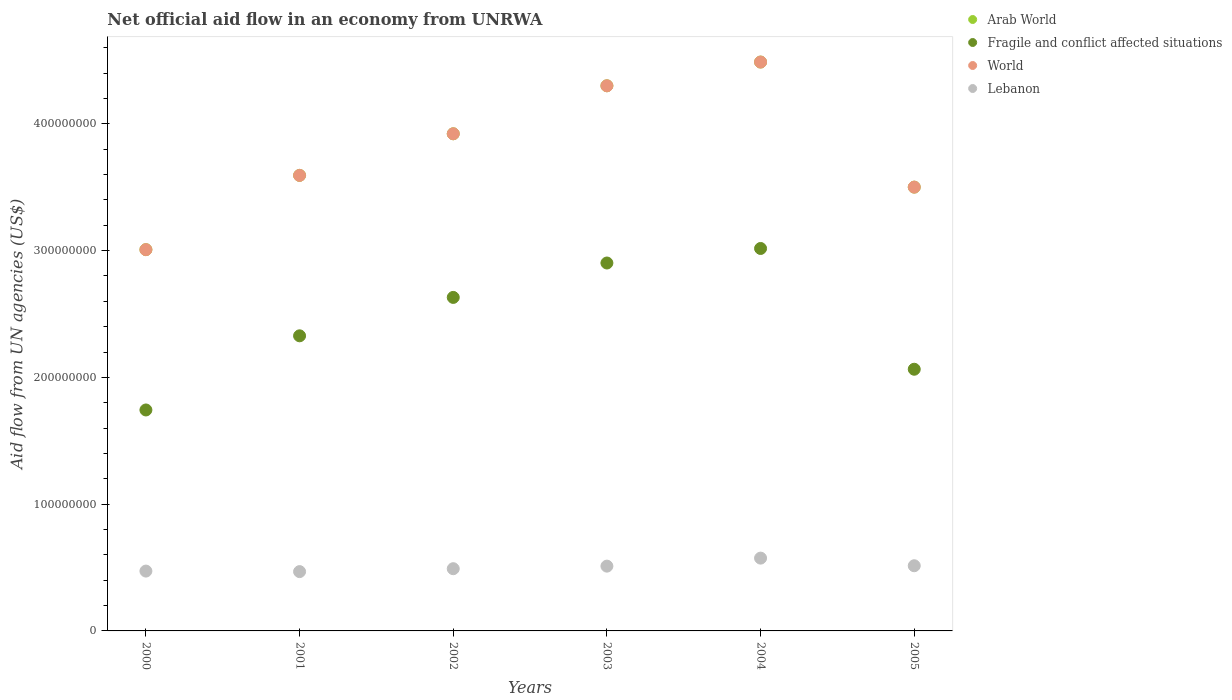How many different coloured dotlines are there?
Your answer should be very brief. 4. What is the net official aid flow in Lebanon in 2002?
Offer a terse response. 4.91e+07. Across all years, what is the maximum net official aid flow in Lebanon?
Offer a terse response. 5.74e+07. Across all years, what is the minimum net official aid flow in Fragile and conflict affected situations?
Make the answer very short. 1.74e+08. In which year was the net official aid flow in Lebanon maximum?
Your response must be concise. 2004. In which year was the net official aid flow in World minimum?
Provide a succinct answer. 2000. What is the total net official aid flow in Lebanon in the graph?
Provide a short and direct response. 3.03e+08. What is the difference between the net official aid flow in Arab World in 2001 and that in 2002?
Give a very brief answer. -3.28e+07. What is the difference between the net official aid flow in Fragile and conflict affected situations in 2004 and the net official aid flow in Lebanon in 2005?
Your response must be concise. 2.50e+08. What is the average net official aid flow in Lebanon per year?
Your answer should be very brief. 5.05e+07. In the year 2000, what is the difference between the net official aid flow in Fragile and conflict affected situations and net official aid flow in Arab World?
Your answer should be very brief. -1.26e+08. What is the ratio of the net official aid flow in World in 2002 to that in 2005?
Keep it short and to the point. 1.12. Is the net official aid flow in World in 2002 less than that in 2004?
Offer a terse response. Yes. Is the difference between the net official aid flow in Fragile and conflict affected situations in 2002 and 2005 greater than the difference between the net official aid flow in Arab World in 2002 and 2005?
Keep it short and to the point. Yes. What is the difference between the highest and the second highest net official aid flow in Arab World?
Keep it short and to the point. 1.87e+07. What is the difference between the highest and the lowest net official aid flow in Lebanon?
Your answer should be compact. 1.06e+07. In how many years, is the net official aid flow in World greater than the average net official aid flow in World taken over all years?
Offer a terse response. 3. Is it the case that in every year, the sum of the net official aid flow in Arab World and net official aid flow in World  is greater than the sum of net official aid flow in Lebanon and net official aid flow in Fragile and conflict affected situations?
Your answer should be very brief. No. Does the net official aid flow in Arab World monotonically increase over the years?
Give a very brief answer. No. How many dotlines are there?
Offer a very short reply. 4. How many years are there in the graph?
Give a very brief answer. 6. What is the difference between two consecutive major ticks on the Y-axis?
Offer a terse response. 1.00e+08. Are the values on the major ticks of Y-axis written in scientific E-notation?
Offer a terse response. No. Does the graph contain grids?
Your answer should be compact. No. Where does the legend appear in the graph?
Keep it short and to the point. Top right. How many legend labels are there?
Keep it short and to the point. 4. How are the legend labels stacked?
Your response must be concise. Vertical. What is the title of the graph?
Your response must be concise. Net official aid flow in an economy from UNRWA. What is the label or title of the Y-axis?
Provide a succinct answer. Aid flow from UN agencies (US$). What is the Aid flow from UN agencies (US$) of Arab World in 2000?
Give a very brief answer. 3.01e+08. What is the Aid flow from UN agencies (US$) in Fragile and conflict affected situations in 2000?
Your answer should be compact. 1.74e+08. What is the Aid flow from UN agencies (US$) of World in 2000?
Provide a succinct answer. 3.01e+08. What is the Aid flow from UN agencies (US$) of Lebanon in 2000?
Keep it short and to the point. 4.72e+07. What is the Aid flow from UN agencies (US$) of Arab World in 2001?
Ensure brevity in your answer.  3.59e+08. What is the Aid flow from UN agencies (US$) in Fragile and conflict affected situations in 2001?
Make the answer very short. 2.33e+08. What is the Aid flow from UN agencies (US$) in World in 2001?
Keep it short and to the point. 3.59e+08. What is the Aid flow from UN agencies (US$) in Lebanon in 2001?
Your answer should be compact. 4.68e+07. What is the Aid flow from UN agencies (US$) of Arab World in 2002?
Your response must be concise. 3.92e+08. What is the Aid flow from UN agencies (US$) in Fragile and conflict affected situations in 2002?
Keep it short and to the point. 2.63e+08. What is the Aid flow from UN agencies (US$) of World in 2002?
Your response must be concise. 3.92e+08. What is the Aid flow from UN agencies (US$) of Lebanon in 2002?
Your answer should be very brief. 4.91e+07. What is the Aid flow from UN agencies (US$) in Arab World in 2003?
Offer a terse response. 4.30e+08. What is the Aid flow from UN agencies (US$) in Fragile and conflict affected situations in 2003?
Your answer should be compact. 2.90e+08. What is the Aid flow from UN agencies (US$) of World in 2003?
Your answer should be compact. 4.30e+08. What is the Aid flow from UN agencies (US$) in Lebanon in 2003?
Give a very brief answer. 5.11e+07. What is the Aid flow from UN agencies (US$) of Arab World in 2004?
Ensure brevity in your answer.  4.49e+08. What is the Aid flow from UN agencies (US$) of Fragile and conflict affected situations in 2004?
Provide a succinct answer. 3.02e+08. What is the Aid flow from UN agencies (US$) in World in 2004?
Ensure brevity in your answer.  4.49e+08. What is the Aid flow from UN agencies (US$) in Lebanon in 2004?
Make the answer very short. 5.74e+07. What is the Aid flow from UN agencies (US$) of Arab World in 2005?
Make the answer very short. 3.50e+08. What is the Aid flow from UN agencies (US$) of Fragile and conflict affected situations in 2005?
Give a very brief answer. 2.06e+08. What is the Aid flow from UN agencies (US$) in World in 2005?
Your answer should be very brief. 3.50e+08. What is the Aid flow from UN agencies (US$) in Lebanon in 2005?
Provide a short and direct response. 5.14e+07. Across all years, what is the maximum Aid flow from UN agencies (US$) in Arab World?
Ensure brevity in your answer.  4.49e+08. Across all years, what is the maximum Aid flow from UN agencies (US$) in Fragile and conflict affected situations?
Make the answer very short. 3.02e+08. Across all years, what is the maximum Aid flow from UN agencies (US$) of World?
Provide a succinct answer. 4.49e+08. Across all years, what is the maximum Aid flow from UN agencies (US$) of Lebanon?
Your answer should be very brief. 5.74e+07. Across all years, what is the minimum Aid flow from UN agencies (US$) in Arab World?
Ensure brevity in your answer.  3.01e+08. Across all years, what is the minimum Aid flow from UN agencies (US$) in Fragile and conflict affected situations?
Ensure brevity in your answer.  1.74e+08. Across all years, what is the minimum Aid flow from UN agencies (US$) in World?
Keep it short and to the point. 3.01e+08. Across all years, what is the minimum Aid flow from UN agencies (US$) of Lebanon?
Provide a short and direct response. 4.68e+07. What is the total Aid flow from UN agencies (US$) of Arab World in the graph?
Keep it short and to the point. 2.28e+09. What is the total Aid flow from UN agencies (US$) in Fragile and conflict affected situations in the graph?
Your answer should be compact. 1.47e+09. What is the total Aid flow from UN agencies (US$) in World in the graph?
Your answer should be very brief. 2.28e+09. What is the total Aid flow from UN agencies (US$) in Lebanon in the graph?
Provide a succinct answer. 3.03e+08. What is the difference between the Aid flow from UN agencies (US$) of Arab World in 2000 and that in 2001?
Provide a succinct answer. -5.86e+07. What is the difference between the Aid flow from UN agencies (US$) of Fragile and conflict affected situations in 2000 and that in 2001?
Your answer should be very brief. -5.85e+07. What is the difference between the Aid flow from UN agencies (US$) in World in 2000 and that in 2001?
Keep it short and to the point. -5.86e+07. What is the difference between the Aid flow from UN agencies (US$) of Lebanon in 2000 and that in 2001?
Provide a short and direct response. 4.20e+05. What is the difference between the Aid flow from UN agencies (US$) in Arab World in 2000 and that in 2002?
Provide a short and direct response. -9.14e+07. What is the difference between the Aid flow from UN agencies (US$) of Fragile and conflict affected situations in 2000 and that in 2002?
Make the answer very short. -8.88e+07. What is the difference between the Aid flow from UN agencies (US$) in World in 2000 and that in 2002?
Your response must be concise. -9.14e+07. What is the difference between the Aid flow from UN agencies (US$) in Lebanon in 2000 and that in 2002?
Provide a succinct answer. -1.88e+06. What is the difference between the Aid flow from UN agencies (US$) of Arab World in 2000 and that in 2003?
Your response must be concise. -1.29e+08. What is the difference between the Aid flow from UN agencies (US$) of Fragile and conflict affected situations in 2000 and that in 2003?
Make the answer very short. -1.16e+08. What is the difference between the Aid flow from UN agencies (US$) in World in 2000 and that in 2003?
Your answer should be compact. -1.29e+08. What is the difference between the Aid flow from UN agencies (US$) of Lebanon in 2000 and that in 2003?
Provide a short and direct response. -3.90e+06. What is the difference between the Aid flow from UN agencies (US$) in Arab World in 2000 and that in 2004?
Your response must be concise. -1.48e+08. What is the difference between the Aid flow from UN agencies (US$) of Fragile and conflict affected situations in 2000 and that in 2004?
Ensure brevity in your answer.  -1.27e+08. What is the difference between the Aid flow from UN agencies (US$) of World in 2000 and that in 2004?
Your answer should be very brief. -1.48e+08. What is the difference between the Aid flow from UN agencies (US$) in Lebanon in 2000 and that in 2004?
Provide a succinct answer. -1.02e+07. What is the difference between the Aid flow from UN agencies (US$) in Arab World in 2000 and that in 2005?
Provide a succinct answer. -4.93e+07. What is the difference between the Aid flow from UN agencies (US$) of Fragile and conflict affected situations in 2000 and that in 2005?
Offer a terse response. -3.21e+07. What is the difference between the Aid flow from UN agencies (US$) of World in 2000 and that in 2005?
Offer a very short reply. -4.93e+07. What is the difference between the Aid flow from UN agencies (US$) in Lebanon in 2000 and that in 2005?
Make the answer very short. -4.21e+06. What is the difference between the Aid flow from UN agencies (US$) in Arab World in 2001 and that in 2002?
Make the answer very short. -3.28e+07. What is the difference between the Aid flow from UN agencies (US$) of Fragile and conflict affected situations in 2001 and that in 2002?
Your answer should be very brief. -3.03e+07. What is the difference between the Aid flow from UN agencies (US$) in World in 2001 and that in 2002?
Ensure brevity in your answer.  -3.28e+07. What is the difference between the Aid flow from UN agencies (US$) in Lebanon in 2001 and that in 2002?
Provide a short and direct response. -2.30e+06. What is the difference between the Aid flow from UN agencies (US$) of Arab World in 2001 and that in 2003?
Offer a terse response. -7.07e+07. What is the difference between the Aid flow from UN agencies (US$) of Fragile and conflict affected situations in 2001 and that in 2003?
Your answer should be compact. -5.74e+07. What is the difference between the Aid flow from UN agencies (US$) of World in 2001 and that in 2003?
Provide a succinct answer. -7.07e+07. What is the difference between the Aid flow from UN agencies (US$) in Lebanon in 2001 and that in 2003?
Give a very brief answer. -4.32e+06. What is the difference between the Aid flow from UN agencies (US$) in Arab World in 2001 and that in 2004?
Make the answer very short. -8.94e+07. What is the difference between the Aid flow from UN agencies (US$) in Fragile and conflict affected situations in 2001 and that in 2004?
Make the answer very short. -6.89e+07. What is the difference between the Aid flow from UN agencies (US$) of World in 2001 and that in 2004?
Your response must be concise. -8.94e+07. What is the difference between the Aid flow from UN agencies (US$) of Lebanon in 2001 and that in 2004?
Provide a succinct answer. -1.06e+07. What is the difference between the Aid flow from UN agencies (US$) of Arab World in 2001 and that in 2005?
Provide a succinct answer. 9.26e+06. What is the difference between the Aid flow from UN agencies (US$) in Fragile and conflict affected situations in 2001 and that in 2005?
Provide a succinct answer. 2.64e+07. What is the difference between the Aid flow from UN agencies (US$) of World in 2001 and that in 2005?
Keep it short and to the point. 9.26e+06. What is the difference between the Aid flow from UN agencies (US$) in Lebanon in 2001 and that in 2005?
Your answer should be very brief. -4.63e+06. What is the difference between the Aid flow from UN agencies (US$) of Arab World in 2002 and that in 2003?
Provide a succinct answer. -3.79e+07. What is the difference between the Aid flow from UN agencies (US$) in Fragile and conflict affected situations in 2002 and that in 2003?
Your answer should be compact. -2.72e+07. What is the difference between the Aid flow from UN agencies (US$) in World in 2002 and that in 2003?
Your response must be concise. -3.79e+07. What is the difference between the Aid flow from UN agencies (US$) in Lebanon in 2002 and that in 2003?
Give a very brief answer. -2.02e+06. What is the difference between the Aid flow from UN agencies (US$) in Arab World in 2002 and that in 2004?
Your answer should be very brief. -5.66e+07. What is the difference between the Aid flow from UN agencies (US$) of Fragile and conflict affected situations in 2002 and that in 2004?
Provide a short and direct response. -3.86e+07. What is the difference between the Aid flow from UN agencies (US$) of World in 2002 and that in 2004?
Your response must be concise. -5.66e+07. What is the difference between the Aid flow from UN agencies (US$) of Lebanon in 2002 and that in 2004?
Provide a short and direct response. -8.34e+06. What is the difference between the Aid flow from UN agencies (US$) of Arab World in 2002 and that in 2005?
Provide a succinct answer. 4.21e+07. What is the difference between the Aid flow from UN agencies (US$) of Fragile and conflict affected situations in 2002 and that in 2005?
Your response must be concise. 5.67e+07. What is the difference between the Aid flow from UN agencies (US$) in World in 2002 and that in 2005?
Offer a terse response. 4.21e+07. What is the difference between the Aid flow from UN agencies (US$) in Lebanon in 2002 and that in 2005?
Your response must be concise. -2.33e+06. What is the difference between the Aid flow from UN agencies (US$) of Arab World in 2003 and that in 2004?
Offer a very short reply. -1.87e+07. What is the difference between the Aid flow from UN agencies (US$) of Fragile and conflict affected situations in 2003 and that in 2004?
Offer a terse response. -1.15e+07. What is the difference between the Aid flow from UN agencies (US$) in World in 2003 and that in 2004?
Offer a terse response. -1.87e+07. What is the difference between the Aid flow from UN agencies (US$) of Lebanon in 2003 and that in 2004?
Make the answer very short. -6.32e+06. What is the difference between the Aid flow from UN agencies (US$) in Arab World in 2003 and that in 2005?
Offer a very short reply. 8.00e+07. What is the difference between the Aid flow from UN agencies (US$) in Fragile and conflict affected situations in 2003 and that in 2005?
Ensure brevity in your answer.  8.38e+07. What is the difference between the Aid flow from UN agencies (US$) in World in 2003 and that in 2005?
Offer a terse response. 8.00e+07. What is the difference between the Aid flow from UN agencies (US$) of Lebanon in 2003 and that in 2005?
Provide a succinct answer. -3.10e+05. What is the difference between the Aid flow from UN agencies (US$) in Arab World in 2004 and that in 2005?
Provide a succinct answer. 9.87e+07. What is the difference between the Aid flow from UN agencies (US$) of Fragile and conflict affected situations in 2004 and that in 2005?
Provide a succinct answer. 9.53e+07. What is the difference between the Aid flow from UN agencies (US$) of World in 2004 and that in 2005?
Keep it short and to the point. 9.87e+07. What is the difference between the Aid flow from UN agencies (US$) in Lebanon in 2004 and that in 2005?
Provide a succinct answer. 6.01e+06. What is the difference between the Aid flow from UN agencies (US$) of Arab World in 2000 and the Aid flow from UN agencies (US$) of Fragile and conflict affected situations in 2001?
Keep it short and to the point. 6.80e+07. What is the difference between the Aid flow from UN agencies (US$) in Arab World in 2000 and the Aid flow from UN agencies (US$) in World in 2001?
Offer a very short reply. -5.86e+07. What is the difference between the Aid flow from UN agencies (US$) of Arab World in 2000 and the Aid flow from UN agencies (US$) of Lebanon in 2001?
Give a very brief answer. 2.54e+08. What is the difference between the Aid flow from UN agencies (US$) in Fragile and conflict affected situations in 2000 and the Aid flow from UN agencies (US$) in World in 2001?
Offer a very short reply. -1.85e+08. What is the difference between the Aid flow from UN agencies (US$) of Fragile and conflict affected situations in 2000 and the Aid flow from UN agencies (US$) of Lebanon in 2001?
Ensure brevity in your answer.  1.28e+08. What is the difference between the Aid flow from UN agencies (US$) in World in 2000 and the Aid flow from UN agencies (US$) in Lebanon in 2001?
Give a very brief answer. 2.54e+08. What is the difference between the Aid flow from UN agencies (US$) of Arab World in 2000 and the Aid flow from UN agencies (US$) of Fragile and conflict affected situations in 2002?
Keep it short and to the point. 3.77e+07. What is the difference between the Aid flow from UN agencies (US$) of Arab World in 2000 and the Aid flow from UN agencies (US$) of World in 2002?
Your answer should be very brief. -9.14e+07. What is the difference between the Aid flow from UN agencies (US$) in Arab World in 2000 and the Aid flow from UN agencies (US$) in Lebanon in 2002?
Offer a terse response. 2.52e+08. What is the difference between the Aid flow from UN agencies (US$) of Fragile and conflict affected situations in 2000 and the Aid flow from UN agencies (US$) of World in 2002?
Offer a very short reply. -2.18e+08. What is the difference between the Aid flow from UN agencies (US$) in Fragile and conflict affected situations in 2000 and the Aid flow from UN agencies (US$) in Lebanon in 2002?
Your response must be concise. 1.25e+08. What is the difference between the Aid flow from UN agencies (US$) of World in 2000 and the Aid flow from UN agencies (US$) of Lebanon in 2002?
Your answer should be compact. 2.52e+08. What is the difference between the Aid flow from UN agencies (US$) of Arab World in 2000 and the Aid flow from UN agencies (US$) of Fragile and conflict affected situations in 2003?
Make the answer very short. 1.05e+07. What is the difference between the Aid flow from UN agencies (US$) of Arab World in 2000 and the Aid flow from UN agencies (US$) of World in 2003?
Your answer should be very brief. -1.29e+08. What is the difference between the Aid flow from UN agencies (US$) in Arab World in 2000 and the Aid flow from UN agencies (US$) in Lebanon in 2003?
Provide a succinct answer. 2.50e+08. What is the difference between the Aid flow from UN agencies (US$) in Fragile and conflict affected situations in 2000 and the Aid flow from UN agencies (US$) in World in 2003?
Make the answer very short. -2.56e+08. What is the difference between the Aid flow from UN agencies (US$) of Fragile and conflict affected situations in 2000 and the Aid flow from UN agencies (US$) of Lebanon in 2003?
Ensure brevity in your answer.  1.23e+08. What is the difference between the Aid flow from UN agencies (US$) of World in 2000 and the Aid flow from UN agencies (US$) of Lebanon in 2003?
Give a very brief answer. 2.50e+08. What is the difference between the Aid flow from UN agencies (US$) in Arab World in 2000 and the Aid flow from UN agencies (US$) in Fragile and conflict affected situations in 2004?
Provide a succinct answer. -9.30e+05. What is the difference between the Aid flow from UN agencies (US$) of Arab World in 2000 and the Aid flow from UN agencies (US$) of World in 2004?
Offer a terse response. -1.48e+08. What is the difference between the Aid flow from UN agencies (US$) of Arab World in 2000 and the Aid flow from UN agencies (US$) of Lebanon in 2004?
Ensure brevity in your answer.  2.43e+08. What is the difference between the Aid flow from UN agencies (US$) in Fragile and conflict affected situations in 2000 and the Aid flow from UN agencies (US$) in World in 2004?
Make the answer very short. -2.74e+08. What is the difference between the Aid flow from UN agencies (US$) in Fragile and conflict affected situations in 2000 and the Aid flow from UN agencies (US$) in Lebanon in 2004?
Keep it short and to the point. 1.17e+08. What is the difference between the Aid flow from UN agencies (US$) of World in 2000 and the Aid flow from UN agencies (US$) of Lebanon in 2004?
Your answer should be very brief. 2.43e+08. What is the difference between the Aid flow from UN agencies (US$) of Arab World in 2000 and the Aid flow from UN agencies (US$) of Fragile and conflict affected situations in 2005?
Provide a succinct answer. 9.43e+07. What is the difference between the Aid flow from UN agencies (US$) in Arab World in 2000 and the Aid flow from UN agencies (US$) in World in 2005?
Offer a very short reply. -4.93e+07. What is the difference between the Aid flow from UN agencies (US$) of Arab World in 2000 and the Aid flow from UN agencies (US$) of Lebanon in 2005?
Your response must be concise. 2.49e+08. What is the difference between the Aid flow from UN agencies (US$) of Fragile and conflict affected situations in 2000 and the Aid flow from UN agencies (US$) of World in 2005?
Provide a short and direct response. -1.76e+08. What is the difference between the Aid flow from UN agencies (US$) of Fragile and conflict affected situations in 2000 and the Aid flow from UN agencies (US$) of Lebanon in 2005?
Make the answer very short. 1.23e+08. What is the difference between the Aid flow from UN agencies (US$) in World in 2000 and the Aid flow from UN agencies (US$) in Lebanon in 2005?
Offer a very short reply. 2.49e+08. What is the difference between the Aid flow from UN agencies (US$) of Arab World in 2001 and the Aid flow from UN agencies (US$) of Fragile and conflict affected situations in 2002?
Keep it short and to the point. 9.63e+07. What is the difference between the Aid flow from UN agencies (US$) of Arab World in 2001 and the Aid flow from UN agencies (US$) of World in 2002?
Your answer should be compact. -3.28e+07. What is the difference between the Aid flow from UN agencies (US$) in Arab World in 2001 and the Aid flow from UN agencies (US$) in Lebanon in 2002?
Make the answer very short. 3.10e+08. What is the difference between the Aid flow from UN agencies (US$) in Fragile and conflict affected situations in 2001 and the Aid flow from UN agencies (US$) in World in 2002?
Provide a succinct answer. -1.59e+08. What is the difference between the Aid flow from UN agencies (US$) of Fragile and conflict affected situations in 2001 and the Aid flow from UN agencies (US$) of Lebanon in 2002?
Your response must be concise. 1.84e+08. What is the difference between the Aid flow from UN agencies (US$) in World in 2001 and the Aid flow from UN agencies (US$) in Lebanon in 2002?
Your answer should be very brief. 3.10e+08. What is the difference between the Aid flow from UN agencies (US$) of Arab World in 2001 and the Aid flow from UN agencies (US$) of Fragile and conflict affected situations in 2003?
Offer a very short reply. 6.91e+07. What is the difference between the Aid flow from UN agencies (US$) of Arab World in 2001 and the Aid flow from UN agencies (US$) of World in 2003?
Your answer should be very brief. -7.07e+07. What is the difference between the Aid flow from UN agencies (US$) in Arab World in 2001 and the Aid flow from UN agencies (US$) in Lebanon in 2003?
Provide a succinct answer. 3.08e+08. What is the difference between the Aid flow from UN agencies (US$) in Fragile and conflict affected situations in 2001 and the Aid flow from UN agencies (US$) in World in 2003?
Offer a very short reply. -1.97e+08. What is the difference between the Aid flow from UN agencies (US$) in Fragile and conflict affected situations in 2001 and the Aid flow from UN agencies (US$) in Lebanon in 2003?
Give a very brief answer. 1.82e+08. What is the difference between the Aid flow from UN agencies (US$) of World in 2001 and the Aid flow from UN agencies (US$) of Lebanon in 2003?
Your answer should be very brief. 3.08e+08. What is the difference between the Aid flow from UN agencies (US$) of Arab World in 2001 and the Aid flow from UN agencies (US$) of Fragile and conflict affected situations in 2004?
Offer a very short reply. 5.77e+07. What is the difference between the Aid flow from UN agencies (US$) of Arab World in 2001 and the Aid flow from UN agencies (US$) of World in 2004?
Your answer should be compact. -8.94e+07. What is the difference between the Aid flow from UN agencies (US$) of Arab World in 2001 and the Aid flow from UN agencies (US$) of Lebanon in 2004?
Provide a succinct answer. 3.02e+08. What is the difference between the Aid flow from UN agencies (US$) of Fragile and conflict affected situations in 2001 and the Aid flow from UN agencies (US$) of World in 2004?
Provide a succinct answer. -2.16e+08. What is the difference between the Aid flow from UN agencies (US$) in Fragile and conflict affected situations in 2001 and the Aid flow from UN agencies (US$) in Lebanon in 2004?
Provide a succinct answer. 1.75e+08. What is the difference between the Aid flow from UN agencies (US$) in World in 2001 and the Aid flow from UN agencies (US$) in Lebanon in 2004?
Keep it short and to the point. 3.02e+08. What is the difference between the Aid flow from UN agencies (US$) in Arab World in 2001 and the Aid flow from UN agencies (US$) in Fragile and conflict affected situations in 2005?
Provide a short and direct response. 1.53e+08. What is the difference between the Aid flow from UN agencies (US$) in Arab World in 2001 and the Aid flow from UN agencies (US$) in World in 2005?
Offer a terse response. 9.26e+06. What is the difference between the Aid flow from UN agencies (US$) of Arab World in 2001 and the Aid flow from UN agencies (US$) of Lebanon in 2005?
Offer a very short reply. 3.08e+08. What is the difference between the Aid flow from UN agencies (US$) in Fragile and conflict affected situations in 2001 and the Aid flow from UN agencies (US$) in World in 2005?
Offer a very short reply. -1.17e+08. What is the difference between the Aid flow from UN agencies (US$) of Fragile and conflict affected situations in 2001 and the Aid flow from UN agencies (US$) of Lebanon in 2005?
Give a very brief answer. 1.81e+08. What is the difference between the Aid flow from UN agencies (US$) of World in 2001 and the Aid flow from UN agencies (US$) of Lebanon in 2005?
Your answer should be very brief. 3.08e+08. What is the difference between the Aid flow from UN agencies (US$) of Arab World in 2002 and the Aid flow from UN agencies (US$) of Fragile and conflict affected situations in 2003?
Your answer should be very brief. 1.02e+08. What is the difference between the Aid flow from UN agencies (US$) in Arab World in 2002 and the Aid flow from UN agencies (US$) in World in 2003?
Keep it short and to the point. -3.79e+07. What is the difference between the Aid flow from UN agencies (US$) of Arab World in 2002 and the Aid flow from UN agencies (US$) of Lebanon in 2003?
Provide a short and direct response. 3.41e+08. What is the difference between the Aid flow from UN agencies (US$) in Fragile and conflict affected situations in 2002 and the Aid flow from UN agencies (US$) in World in 2003?
Give a very brief answer. -1.67e+08. What is the difference between the Aid flow from UN agencies (US$) in Fragile and conflict affected situations in 2002 and the Aid flow from UN agencies (US$) in Lebanon in 2003?
Give a very brief answer. 2.12e+08. What is the difference between the Aid flow from UN agencies (US$) of World in 2002 and the Aid flow from UN agencies (US$) of Lebanon in 2003?
Provide a succinct answer. 3.41e+08. What is the difference between the Aid flow from UN agencies (US$) of Arab World in 2002 and the Aid flow from UN agencies (US$) of Fragile and conflict affected situations in 2004?
Make the answer very short. 9.05e+07. What is the difference between the Aid flow from UN agencies (US$) in Arab World in 2002 and the Aid flow from UN agencies (US$) in World in 2004?
Offer a terse response. -5.66e+07. What is the difference between the Aid flow from UN agencies (US$) of Arab World in 2002 and the Aid flow from UN agencies (US$) of Lebanon in 2004?
Offer a very short reply. 3.35e+08. What is the difference between the Aid flow from UN agencies (US$) of Fragile and conflict affected situations in 2002 and the Aid flow from UN agencies (US$) of World in 2004?
Offer a terse response. -1.86e+08. What is the difference between the Aid flow from UN agencies (US$) of Fragile and conflict affected situations in 2002 and the Aid flow from UN agencies (US$) of Lebanon in 2004?
Provide a short and direct response. 2.06e+08. What is the difference between the Aid flow from UN agencies (US$) in World in 2002 and the Aid flow from UN agencies (US$) in Lebanon in 2004?
Keep it short and to the point. 3.35e+08. What is the difference between the Aid flow from UN agencies (US$) in Arab World in 2002 and the Aid flow from UN agencies (US$) in Fragile and conflict affected situations in 2005?
Give a very brief answer. 1.86e+08. What is the difference between the Aid flow from UN agencies (US$) in Arab World in 2002 and the Aid flow from UN agencies (US$) in World in 2005?
Make the answer very short. 4.21e+07. What is the difference between the Aid flow from UN agencies (US$) in Arab World in 2002 and the Aid flow from UN agencies (US$) in Lebanon in 2005?
Your response must be concise. 3.41e+08. What is the difference between the Aid flow from UN agencies (US$) of Fragile and conflict affected situations in 2002 and the Aid flow from UN agencies (US$) of World in 2005?
Give a very brief answer. -8.70e+07. What is the difference between the Aid flow from UN agencies (US$) in Fragile and conflict affected situations in 2002 and the Aid flow from UN agencies (US$) in Lebanon in 2005?
Offer a very short reply. 2.12e+08. What is the difference between the Aid flow from UN agencies (US$) in World in 2002 and the Aid flow from UN agencies (US$) in Lebanon in 2005?
Your response must be concise. 3.41e+08. What is the difference between the Aid flow from UN agencies (US$) of Arab World in 2003 and the Aid flow from UN agencies (US$) of Fragile and conflict affected situations in 2004?
Provide a short and direct response. 1.28e+08. What is the difference between the Aid flow from UN agencies (US$) in Arab World in 2003 and the Aid flow from UN agencies (US$) in World in 2004?
Provide a short and direct response. -1.87e+07. What is the difference between the Aid flow from UN agencies (US$) in Arab World in 2003 and the Aid flow from UN agencies (US$) in Lebanon in 2004?
Provide a short and direct response. 3.73e+08. What is the difference between the Aid flow from UN agencies (US$) in Fragile and conflict affected situations in 2003 and the Aid flow from UN agencies (US$) in World in 2004?
Make the answer very short. -1.59e+08. What is the difference between the Aid flow from UN agencies (US$) in Fragile and conflict affected situations in 2003 and the Aid flow from UN agencies (US$) in Lebanon in 2004?
Keep it short and to the point. 2.33e+08. What is the difference between the Aid flow from UN agencies (US$) of World in 2003 and the Aid flow from UN agencies (US$) of Lebanon in 2004?
Give a very brief answer. 3.73e+08. What is the difference between the Aid flow from UN agencies (US$) in Arab World in 2003 and the Aid flow from UN agencies (US$) in Fragile and conflict affected situations in 2005?
Your answer should be very brief. 2.24e+08. What is the difference between the Aid flow from UN agencies (US$) in Arab World in 2003 and the Aid flow from UN agencies (US$) in World in 2005?
Provide a succinct answer. 8.00e+07. What is the difference between the Aid flow from UN agencies (US$) of Arab World in 2003 and the Aid flow from UN agencies (US$) of Lebanon in 2005?
Offer a terse response. 3.79e+08. What is the difference between the Aid flow from UN agencies (US$) of Fragile and conflict affected situations in 2003 and the Aid flow from UN agencies (US$) of World in 2005?
Your response must be concise. -5.99e+07. What is the difference between the Aid flow from UN agencies (US$) of Fragile and conflict affected situations in 2003 and the Aid flow from UN agencies (US$) of Lebanon in 2005?
Provide a succinct answer. 2.39e+08. What is the difference between the Aid flow from UN agencies (US$) of World in 2003 and the Aid flow from UN agencies (US$) of Lebanon in 2005?
Make the answer very short. 3.79e+08. What is the difference between the Aid flow from UN agencies (US$) in Arab World in 2004 and the Aid flow from UN agencies (US$) in Fragile and conflict affected situations in 2005?
Keep it short and to the point. 2.42e+08. What is the difference between the Aid flow from UN agencies (US$) of Arab World in 2004 and the Aid flow from UN agencies (US$) of World in 2005?
Offer a very short reply. 9.87e+07. What is the difference between the Aid flow from UN agencies (US$) in Arab World in 2004 and the Aid flow from UN agencies (US$) in Lebanon in 2005?
Ensure brevity in your answer.  3.97e+08. What is the difference between the Aid flow from UN agencies (US$) of Fragile and conflict affected situations in 2004 and the Aid flow from UN agencies (US$) of World in 2005?
Offer a terse response. -4.84e+07. What is the difference between the Aid flow from UN agencies (US$) in Fragile and conflict affected situations in 2004 and the Aid flow from UN agencies (US$) in Lebanon in 2005?
Your response must be concise. 2.50e+08. What is the difference between the Aid flow from UN agencies (US$) in World in 2004 and the Aid flow from UN agencies (US$) in Lebanon in 2005?
Offer a terse response. 3.97e+08. What is the average Aid flow from UN agencies (US$) of Arab World per year?
Offer a terse response. 3.80e+08. What is the average Aid flow from UN agencies (US$) in Fragile and conflict affected situations per year?
Offer a terse response. 2.45e+08. What is the average Aid flow from UN agencies (US$) of World per year?
Ensure brevity in your answer.  3.80e+08. What is the average Aid flow from UN agencies (US$) of Lebanon per year?
Provide a succinct answer. 5.05e+07. In the year 2000, what is the difference between the Aid flow from UN agencies (US$) in Arab World and Aid flow from UN agencies (US$) in Fragile and conflict affected situations?
Provide a succinct answer. 1.26e+08. In the year 2000, what is the difference between the Aid flow from UN agencies (US$) in Arab World and Aid flow from UN agencies (US$) in Lebanon?
Keep it short and to the point. 2.54e+08. In the year 2000, what is the difference between the Aid flow from UN agencies (US$) of Fragile and conflict affected situations and Aid flow from UN agencies (US$) of World?
Provide a short and direct response. -1.26e+08. In the year 2000, what is the difference between the Aid flow from UN agencies (US$) in Fragile and conflict affected situations and Aid flow from UN agencies (US$) in Lebanon?
Provide a succinct answer. 1.27e+08. In the year 2000, what is the difference between the Aid flow from UN agencies (US$) in World and Aid flow from UN agencies (US$) in Lebanon?
Ensure brevity in your answer.  2.54e+08. In the year 2001, what is the difference between the Aid flow from UN agencies (US$) of Arab World and Aid flow from UN agencies (US$) of Fragile and conflict affected situations?
Offer a very short reply. 1.27e+08. In the year 2001, what is the difference between the Aid flow from UN agencies (US$) in Arab World and Aid flow from UN agencies (US$) in Lebanon?
Offer a terse response. 3.13e+08. In the year 2001, what is the difference between the Aid flow from UN agencies (US$) in Fragile and conflict affected situations and Aid flow from UN agencies (US$) in World?
Offer a terse response. -1.27e+08. In the year 2001, what is the difference between the Aid flow from UN agencies (US$) in Fragile and conflict affected situations and Aid flow from UN agencies (US$) in Lebanon?
Make the answer very short. 1.86e+08. In the year 2001, what is the difference between the Aid flow from UN agencies (US$) in World and Aid flow from UN agencies (US$) in Lebanon?
Ensure brevity in your answer.  3.13e+08. In the year 2002, what is the difference between the Aid flow from UN agencies (US$) of Arab World and Aid flow from UN agencies (US$) of Fragile and conflict affected situations?
Keep it short and to the point. 1.29e+08. In the year 2002, what is the difference between the Aid flow from UN agencies (US$) of Arab World and Aid flow from UN agencies (US$) of World?
Keep it short and to the point. 0. In the year 2002, what is the difference between the Aid flow from UN agencies (US$) of Arab World and Aid flow from UN agencies (US$) of Lebanon?
Make the answer very short. 3.43e+08. In the year 2002, what is the difference between the Aid flow from UN agencies (US$) in Fragile and conflict affected situations and Aid flow from UN agencies (US$) in World?
Provide a short and direct response. -1.29e+08. In the year 2002, what is the difference between the Aid flow from UN agencies (US$) in Fragile and conflict affected situations and Aid flow from UN agencies (US$) in Lebanon?
Provide a short and direct response. 2.14e+08. In the year 2002, what is the difference between the Aid flow from UN agencies (US$) in World and Aid flow from UN agencies (US$) in Lebanon?
Provide a short and direct response. 3.43e+08. In the year 2003, what is the difference between the Aid flow from UN agencies (US$) in Arab World and Aid flow from UN agencies (US$) in Fragile and conflict affected situations?
Give a very brief answer. 1.40e+08. In the year 2003, what is the difference between the Aid flow from UN agencies (US$) in Arab World and Aid flow from UN agencies (US$) in World?
Ensure brevity in your answer.  0. In the year 2003, what is the difference between the Aid flow from UN agencies (US$) in Arab World and Aid flow from UN agencies (US$) in Lebanon?
Give a very brief answer. 3.79e+08. In the year 2003, what is the difference between the Aid flow from UN agencies (US$) of Fragile and conflict affected situations and Aid flow from UN agencies (US$) of World?
Give a very brief answer. -1.40e+08. In the year 2003, what is the difference between the Aid flow from UN agencies (US$) in Fragile and conflict affected situations and Aid flow from UN agencies (US$) in Lebanon?
Keep it short and to the point. 2.39e+08. In the year 2003, what is the difference between the Aid flow from UN agencies (US$) of World and Aid flow from UN agencies (US$) of Lebanon?
Your answer should be very brief. 3.79e+08. In the year 2004, what is the difference between the Aid flow from UN agencies (US$) of Arab World and Aid flow from UN agencies (US$) of Fragile and conflict affected situations?
Your answer should be very brief. 1.47e+08. In the year 2004, what is the difference between the Aid flow from UN agencies (US$) in Arab World and Aid flow from UN agencies (US$) in Lebanon?
Your answer should be compact. 3.91e+08. In the year 2004, what is the difference between the Aid flow from UN agencies (US$) in Fragile and conflict affected situations and Aid flow from UN agencies (US$) in World?
Give a very brief answer. -1.47e+08. In the year 2004, what is the difference between the Aid flow from UN agencies (US$) of Fragile and conflict affected situations and Aid flow from UN agencies (US$) of Lebanon?
Offer a very short reply. 2.44e+08. In the year 2004, what is the difference between the Aid flow from UN agencies (US$) in World and Aid flow from UN agencies (US$) in Lebanon?
Keep it short and to the point. 3.91e+08. In the year 2005, what is the difference between the Aid flow from UN agencies (US$) in Arab World and Aid flow from UN agencies (US$) in Fragile and conflict affected situations?
Make the answer very short. 1.44e+08. In the year 2005, what is the difference between the Aid flow from UN agencies (US$) in Arab World and Aid flow from UN agencies (US$) in World?
Make the answer very short. 0. In the year 2005, what is the difference between the Aid flow from UN agencies (US$) of Arab World and Aid flow from UN agencies (US$) of Lebanon?
Keep it short and to the point. 2.99e+08. In the year 2005, what is the difference between the Aid flow from UN agencies (US$) in Fragile and conflict affected situations and Aid flow from UN agencies (US$) in World?
Offer a very short reply. -1.44e+08. In the year 2005, what is the difference between the Aid flow from UN agencies (US$) in Fragile and conflict affected situations and Aid flow from UN agencies (US$) in Lebanon?
Your response must be concise. 1.55e+08. In the year 2005, what is the difference between the Aid flow from UN agencies (US$) in World and Aid flow from UN agencies (US$) in Lebanon?
Ensure brevity in your answer.  2.99e+08. What is the ratio of the Aid flow from UN agencies (US$) in Arab World in 2000 to that in 2001?
Your response must be concise. 0.84. What is the ratio of the Aid flow from UN agencies (US$) in Fragile and conflict affected situations in 2000 to that in 2001?
Offer a terse response. 0.75. What is the ratio of the Aid flow from UN agencies (US$) in World in 2000 to that in 2001?
Offer a terse response. 0.84. What is the ratio of the Aid flow from UN agencies (US$) of Lebanon in 2000 to that in 2001?
Offer a very short reply. 1.01. What is the ratio of the Aid flow from UN agencies (US$) in Arab World in 2000 to that in 2002?
Offer a terse response. 0.77. What is the ratio of the Aid flow from UN agencies (US$) of Fragile and conflict affected situations in 2000 to that in 2002?
Give a very brief answer. 0.66. What is the ratio of the Aid flow from UN agencies (US$) of World in 2000 to that in 2002?
Offer a terse response. 0.77. What is the ratio of the Aid flow from UN agencies (US$) of Lebanon in 2000 to that in 2002?
Provide a short and direct response. 0.96. What is the ratio of the Aid flow from UN agencies (US$) in Arab World in 2000 to that in 2003?
Offer a very short reply. 0.7. What is the ratio of the Aid flow from UN agencies (US$) of Fragile and conflict affected situations in 2000 to that in 2003?
Make the answer very short. 0.6. What is the ratio of the Aid flow from UN agencies (US$) of World in 2000 to that in 2003?
Offer a terse response. 0.7. What is the ratio of the Aid flow from UN agencies (US$) in Lebanon in 2000 to that in 2003?
Offer a terse response. 0.92. What is the ratio of the Aid flow from UN agencies (US$) of Arab World in 2000 to that in 2004?
Give a very brief answer. 0.67. What is the ratio of the Aid flow from UN agencies (US$) in Fragile and conflict affected situations in 2000 to that in 2004?
Offer a very short reply. 0.58. What is the ratio of the Aid flow from UN agencies (US$) of World in 2000 to that in 2004?
Keep it short and to the point. 0.67. What is the ratio of the Aid flow from UN agencies (US$) of Lebanon in 2000 to that in 2004?
Offer a very short reply. 0.82. What is the ratio of the Aid flow from UN agencies (US$) of Arab World in 2000 to that in 2005?
Your response must be concise. 0.86. What is the ratio of the Aid flow from UN agencies (US$) in Fragile and conflict affected situations in 2000 to that in 2005?
Provide a succinct answer. 0.84. What is the ratio of the Aid flow from UN agencies (US$) in World in 2000 to that in 2005?
Make the answer very short. 0.86. What is the ratio of the Aid flow from UN agencies (US$) of Lebanon in 2000 to that in 2005?
Offer a very short reply. 0.92. What is the ratio of the Aid flow from UN agencies (US$) of Arab World in 2001 to that in 2002?
Keep it short and to the point. 0.92. What is the ratio of the Aid flow from UN agencies (US$) of Fragile and conflict affected situations in 2001 to that in 2002?
Keep it short and to the point. 0.88. What is the ratio of the Aid flow from UN agencies (US$) of World in 2001 to that in 2002?
Ensure brevity in your answer.  0.92. What is the ratio of the Aid flow from UN agencies (US$) of Lebanon in 2001 to that in 2002?
Give a very brief answer. 0.95. What is the ratio of the Aid flow from UN agencies (US$) in Arab World in 2001 to that in 2003?
Your answer should be very brief. 0.84. What is the ratio of the Aid flow from UN agencies (US$) in Fragile and conflict affected situations in 2001 to that in 2003?
Provide a succinct answer. 0.8. What is the ratio of the Aid flow from UN agencies (US$) in World in 2001 to that in 2003?
Your answer should be compact. 0.84. What is the ratio of the Aid flow from UN agencies (US$) in Lebanon in 2001 to that in 2003?
Make the answer very short. 0.92. What is the ratio of the Aid flow from UN agencies (US$) in Arab World in 2001 to that in 2004?
Keep it short and to the point. 0.8. What is the ratio of the Aid flow from UN agencies (US$) of Fragile and conflict affected situations in 2001 to that in 2004?
Ensure brevity in your answer.  0.77. What is the ratio of the Aid flow from UN agencies (US$) in World in 2001 to that in 2004?
Your response must be concise. 0.8. What is the ratio of the Aid flow from UN agencies (US$) in Lebanon in 2001 to that in 2004?
Ensure brevity in your answer.  0.81. What is the ratio of the Aid flow from UN agencies (US$) of Arab World in 2001 to that in 2005?
Make the answer very short. 1.03. What is the ratio of the Aid flow from UN agencies (US$) in Fragile and conflict affected situations in 2001 to that in 2005?
Your answer should be very brief. 1.13. What is the ratio of the Aid flow from UN agencies (US$) of World in 2001 to that in 2005?
Your response must be concise. 1.03. What is the ratio of the Aid flow from UN agencies (US$) in Lebanon in 2001 to that in 2005?
Offer a terse response. 0.91. What is the ratio of the Aid flow from UN agencies (US$) of Arab World in 2002 to that in 2003?
Your answer should be compact. 0.91. What is the ratio of the Aid flow from UN agencies (US$) in Fragile and conflict affected situations in 2002 to that in 2003?
Your answer should be compact. 0.91. What is the ratio of the Aid flow from UN agencies (US$) in World in 2002 to that in 2003?
Keep it short and to the point. 0.91. What is the ratio of the Aid flow from UN agencies (US$) of Lebanon in 2002 to that in 2003?
Keep it short and to the point. 0.96. What is the ratio of the Aid flow from UN agencies (US$) in Arab World in 2002 to that in 2004?
Your answer should be very brief. 0.87. What is the ratio of the Aid flow from UN agencies (US$) in Fragile and conflict affected situations in 2002 to that in 2004?
Keep it short and to the point. 0.87. What is the ratio of the Aid flow from UN agencies (US$) in World in 2002 to that in 2004?
Your answer should be compact. 0.87. What is the ratio of the Aid flow from UN agencies (US$) in Lebanon in 2002 to that in 2004?
Your answer should be very brief. 0.85. What is the ratio of the Aid flow from UN agencies (US$) in Arab World in 2002 to that in 2005?
Keep it short and to the point. 1.12. What is the ratio of the Aid flow from UN agencies (US$) of Fragile and conflict affected situations in 2002 to that in 2005?
Your response must be concise. 1.27. What is the ratio of the Aid flow from UN agencies (US$) in World in 2002 to that in 2005?
Provide a succinct answer. 1.12. What is the ratio of the Aid flow from UN agencies (US$) of Lebanon in 2002 to that in 2005?
Give a very brief answer. 0.95. What is the ratio of the Aid flow from UN agencies (US$) in Arab World in 2003 to that in 2004?
Your answer should be very brief. 0.96. What is the ratio of the Aid flow from UN agencies (US$) of World in 2003 to that in 2004?
Offer a terse response. 0.96. What is the ratio of the Aid flow from UN agencies (US$) in Lebanon in 2003 to that in 2004?
Keep it short and to the point. 0.89. What is the ratio of the Aid flow from UN agencies (US$) of Arab World in 2003 to that in 2005?
Make the answer very short. 1.23. What is the ratio of the Aid flow from UN agencies (US$) of Fragile and conflict affected situations in 2003 to that in 2005?
Your answer should be compact. 1.41. What is the ratio of the Aid flow from UN agencies (US$) of World in 2003 to that in 2005?
Your answer should be compact. 1.23. What is the ratio of the Aid flow from UN agencies (US$) in Lebanon in 2003 to that in 2005?
Keep it short and to the point. 0.99. What is the ratio of the Aid flow from UN agencies (US$) in Arab World in 2004 to that in 2005?
Keep it short and to the point. 1.28. What is the ratio of the Aid flow from UN agencies (US$) of Fragile and conflict affected situations in 2004 to that in 2005?
Your response must be concise. 1.46. What is the ratio of the Aid flow from UN agencies (US$) of World in 2004 to that in 2005?
Keep it short and to the point. 1.28. What is the ratio of the Aid flow from UN agencies (US$) in Lebanon in 2004 to that in 2005?
Give a very brief answer. 1.12. What is the difference between the highest and the second highest Aid flow from UN agencies (US$) in Arab World?
Your answer should be compact. 1.87e+07. What is the difference between the highest and the second highest Aid flow from UN agencies (US$) in Fragile and conflict affected situations?
Keep it short and to the point. 1.15e+07. What is the difference between the highest and the second highest Aid flow from UN agencies (US$) of World?
Make the answer very short. 1.87e+07. What is the difference between the highest and the second highest Aid flow from UN agencies (US$) of Lebanon?
Provide a short and direct response. 6.01e+06. What is the difference between the highest and the lowest Aid flow from UN agencies (US$) in Arab World?
Make the answer very short. 1.48e+08. What is the difference between the highest and the lowest Aid flow from UN agencies (US$) in Fragile and conflict affected situations?
Give a very brief answer. 1.27e+08. What is the difference between the highest and the lowest Aid flow from UN agencies (US$) of World?
Make the answer very short. 1.48e+08. What is the difference between the highest and the lowest Aid flow from UN agencies (US$) of Lebanon?
Your answer should be very brief. 1.06e+07. 